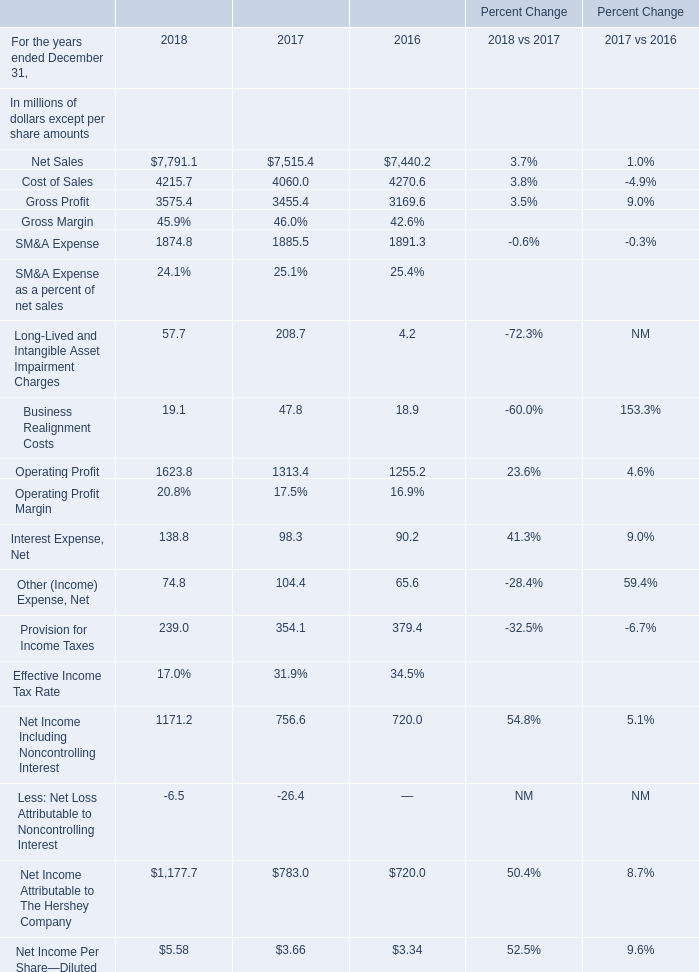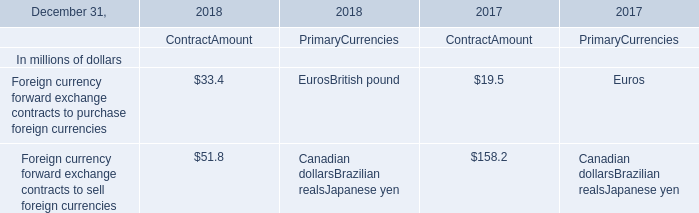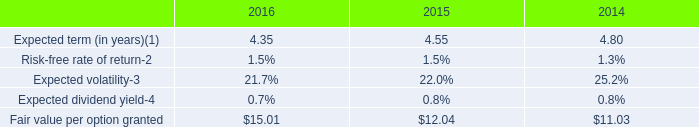based on the tax benefit related to the share-based compensation cost , what is the effective tax rate in 2016? 
Computations: (62 / 211)
Answer: 0.29384. 